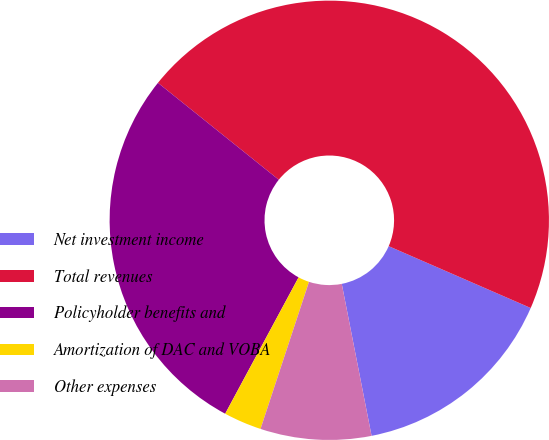Convert chart. <chart><loc_0><loc_0><loc_500><loc_500><pie_chart><fcel>Net investment income<fcel>Total revenues<fcel>Policyholder benefits and<fcel>Amortization of DAC and VOBA<fcel>Other expenses<nl><fcel>15.38%<fcel>45.77%<fcel>27.9%<fcel>2.79%<fcel>8.15%<nl></chart> 